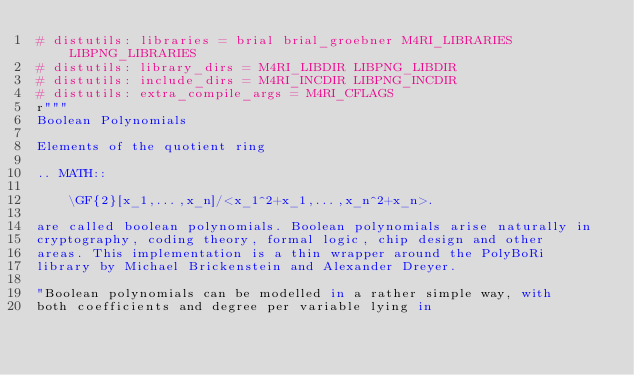Convert code to text. <code><loc_0><loc_0><loc_500><loc_500><_Cython_># distutils: libraries = brial brial_groebner M4RI_LIBRARIES LIBPNG_LIBRARIES
# distutils: library_dirs = M4RI_LIBDIR LIBPNG_LIBDIR
# distutils: include_dirs = M4RI_INCDIR LIBPNG_INCDIR
# distutils: extra_compile_args = M4RI_CFLAGS
r"""
Boolean Polynomials

Elements of the quotient ring

.. MATH::

    \GF{2}[x_1,...,x_n]/<x_1^2+x_1,...,x_n^2+x_n>.

are called boolean polynomials. Boolean polynomials arise naturally in
cryptography, coding theory, formal logic, chip design and other
areas. This implementation is a thin wrapper around the PolyBoRi
library by Michael Brickenstein and Alexander Dreyer.

"Boolean polynomials can be modelled in a rather simple way, with
both coefficients and degree per variable lying in</code> 